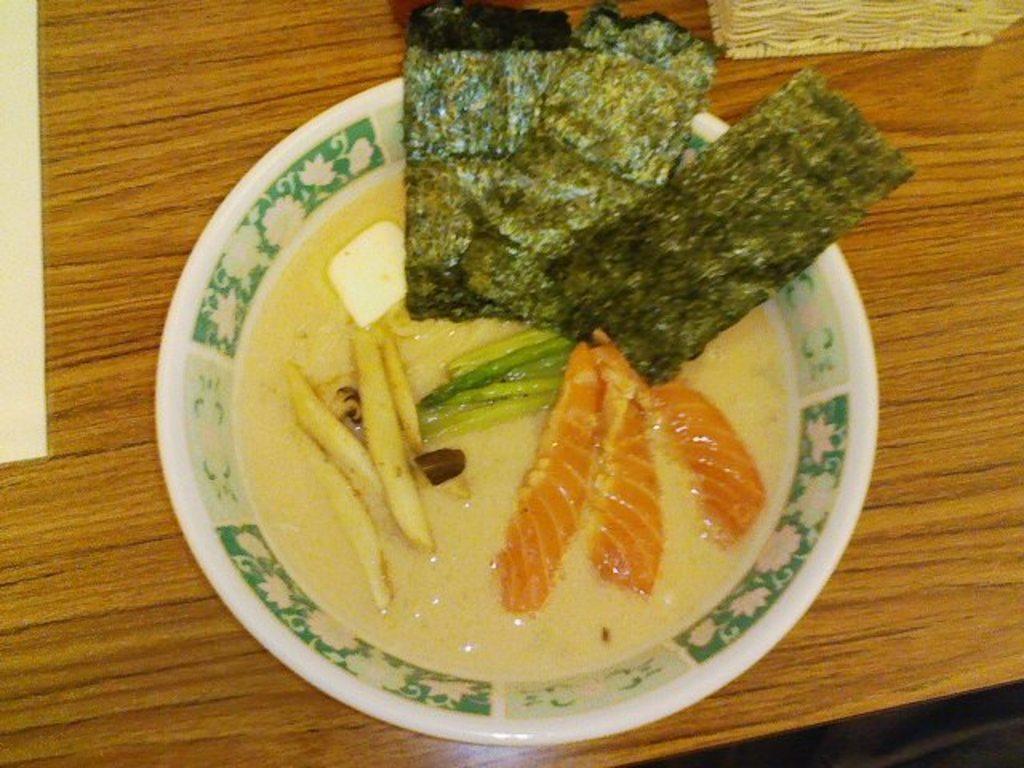Could you give a brief overview of what you see in this image? In the picture we can see a table on it we can see a bowl with soup and some vegetable slices in it. 